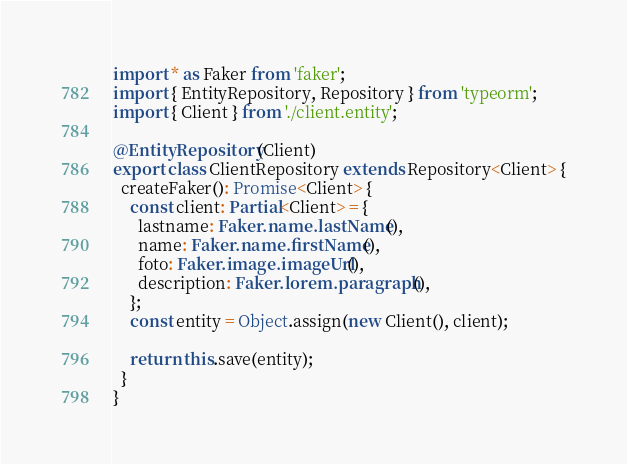<code> <loc_0><loc_0><loc_500><loc_500><_TypeScript_>import * as Faker from 'faker';
import { EntityRepository, Repository } from 'typeorm';
import { Client } from './client.entity';

@EntityRepository(Client)
export class ClientRepository extends Repository<Client> {
  createFaker(): Promise<Client> {
    const client: Partial<Client> = {
      lastname: Faker.name.lastName(),
      name: Faker.name.firstName(),
      foto: Faker.image.imageUrl(),
      description: Faker.lorem.paragraph(),
    };
    const entity = Object.assign(new Client(), client);

    return this.save(entity);
  }
}
</code> 